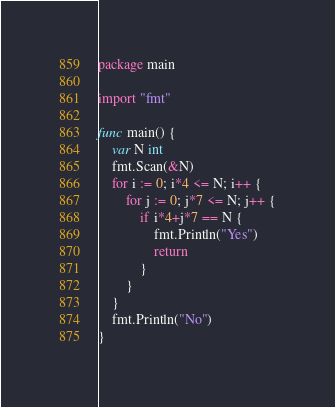<code> <loc_0><loc_0><loc_500><loc_500><_Go_>package main

import "fmt"

func main() {
	var N int
	fmt.Scan(&N)
	for i := 0; i*4 <= N; i++ {
		for j := 0; j*7 <= N; j++ {
			if i*4+j*7 == N {
				fmt.Println("Yes")
				return
			}
		}
	}
	fmt.Println("No")
}
</code> 